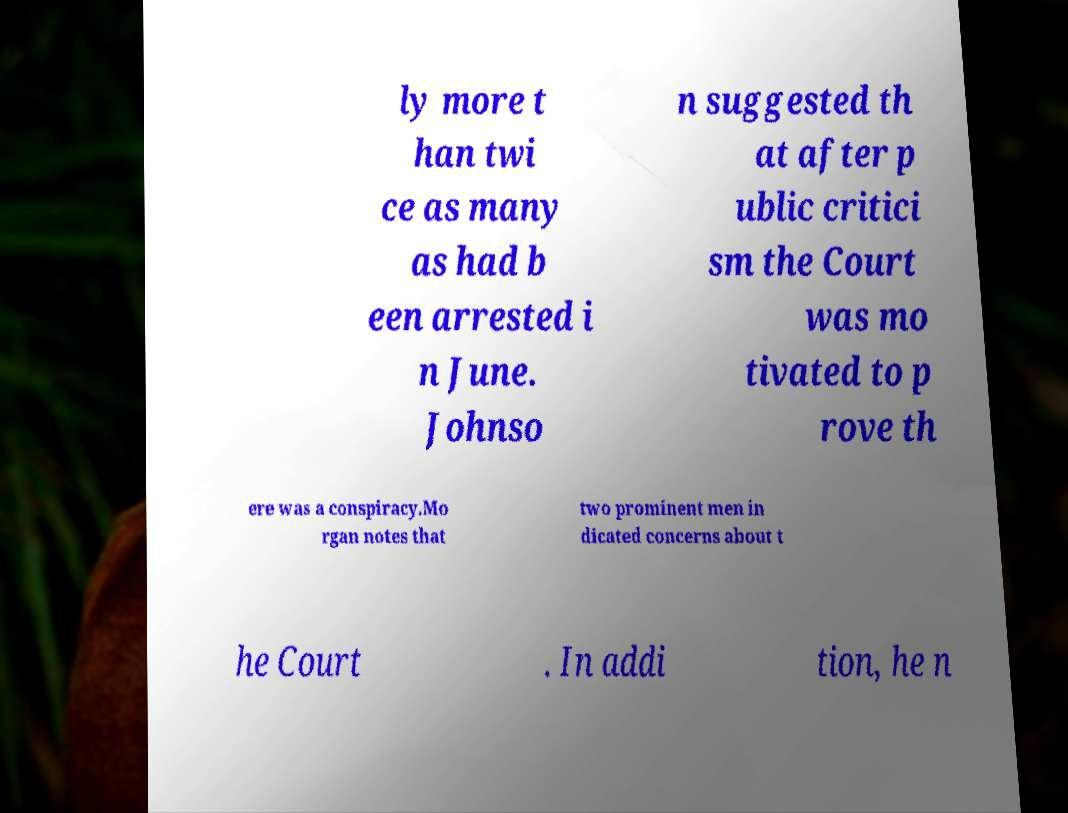For documentation purposes, I need the text within this image transcribed. Could you provide that? ly more t han twi ce as many as had b een arrested i n June. Johnso n suggested th at after p ublic critici sm the Court was mo tivated to p rove th ere was a conspiracy.Mo rgan notes that two prominent men in dicated concerns about t he Court . In addi tion, he n 